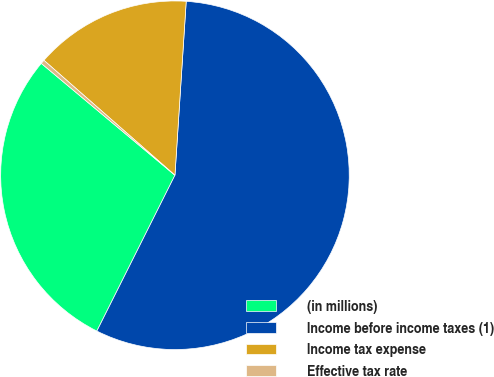Convert chart to OTSL. <chart><loc_0><loc_0><loc_500><loc_500><pie_chart><fcel>(in millions)<fcel>Income before income taxes (1)<fcel>Income tax expense<fcel>Effective tax rate<nl><fcel>28.7%<fcel>56.37%<fcel>14.57%<fcel>0.37%<nl></chart> 